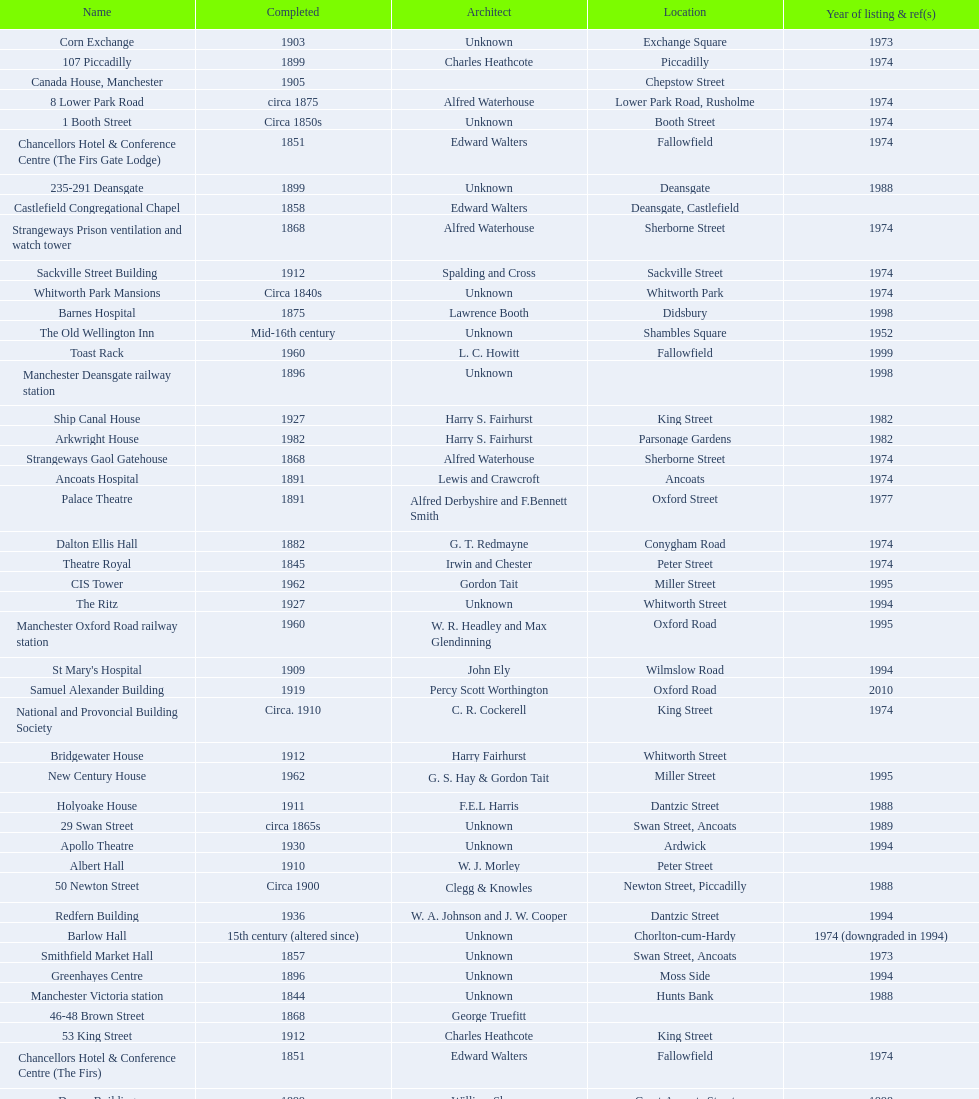Was charles heathcote the architect of ancoats hospital and apollo theatre? No. 